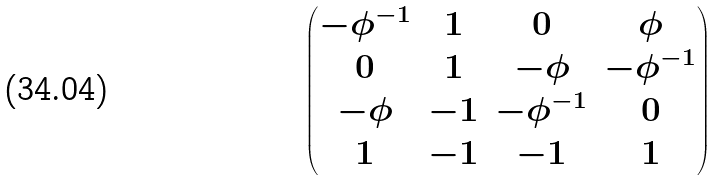Convert formula to latex. <formula><loc_0><loc_0><loc_500><loc_500>\begin{pmatrix} - \phi ^ { - 1 } & 1 & 0 & \phi \\ 0 & 1 & - \phi & - \phi ^ { - 1 } \\ - \phi & - 1 & - \phi ^ { - 1 } & 0 \\ 1 & - 1 & - 1 & 1 \end{pmatrix}</formula> 